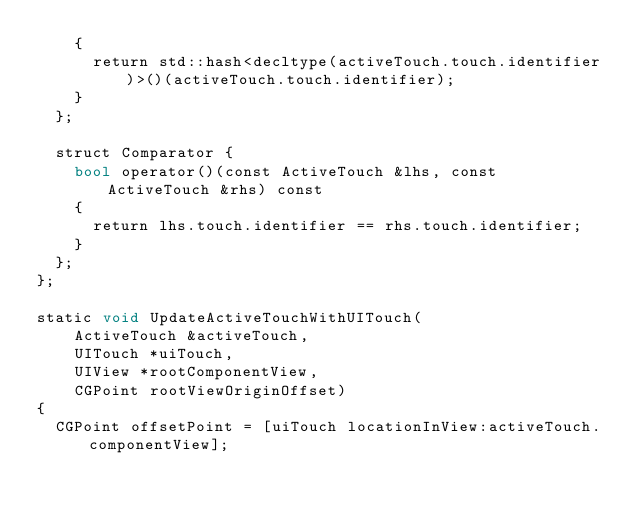<code> <loc_0><loc_0><loc_500><loc_500><_ObjectiveC_>    {
      return std::hash<decltype(activeTouch.touch.identifier)>()(activeTouch.touch.identifier);
    }
  };

  struct Comparator {
    bool operator()(const ActiveTouch &lhs, const ActiveTouch &rhs) const
    {
      return lhs.touch.identifier == rhs.touch.identifier;
    }
  };
};

static void UpdateActiveTouchWithUITouch(
    ActiveTouch &activeTouch,
    UITouch *uiTouch,
    UIView *rootComponentView,
    CGPoint rootViewOriginOffset)
{
  CGPoint offsetPoint = [uiTouch locationInView:activeTouch.componentView];</code> 